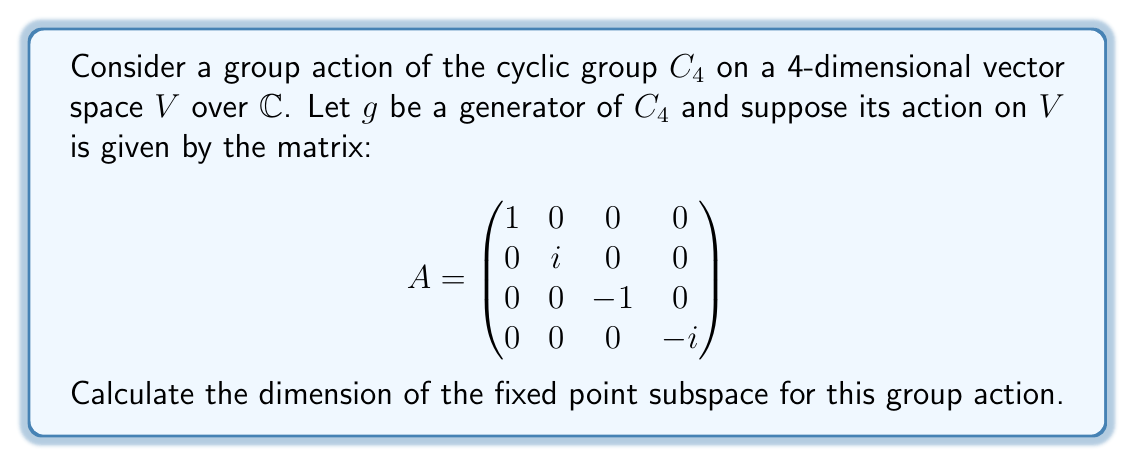Show me your answer to this math problem. Let's approach this step-by-step:

1) The fixed point subspace consists of all vectors $v \in V$ such that $gv = v$ for all $g \in C_4$.

2) Since $g$ is a generator of $C_4$, it's sufficient to find vectors $v$ such that $Av = v$.

3) Let $v = (x_1, x_2, x_3, x_4)^T$. We need to solve the equation:

   $$\begin{pmatrix}
   1 & 0 & 0 & 0 \\
   0 & i & 0 & 0 \\
   0 & 0 & -1 & 0 \\
   0 & 0 & 0 & -i
   \end{pmatrix} \begin{pmatrix} x_1 \\ x_2 \\ x_3 \\ x_4 \end{pmatrix} = \begin{pmatrix} x_1 \\ x_2 \\ x_3 \\ x_4 \end{pmatrix}$$

4) This gives us the system of equations:
   
   $x_1 = x_1$
   $ix_2 = x_2$
   $-x_3 = x_3$
   $-ix_4 = x_4$

5) From these equations:
   - $x_1$ can be any complex number
   - $x_2$ must be 0 (since $i \neq 1$)
   - $x_3$ must be 0 (since $-1 \neq 1$)
   - $x_4$ must be 0 (since $-i \neq 1$)

6) Therefore, the fixed point subspace consists of vectors of the form $(x_1, 0, 0, 0)$ where $x_1 \in \mathbb{C}$.

7) This subspace is 1-dimensional over $\mathbb{C}$.
Answer: 1 